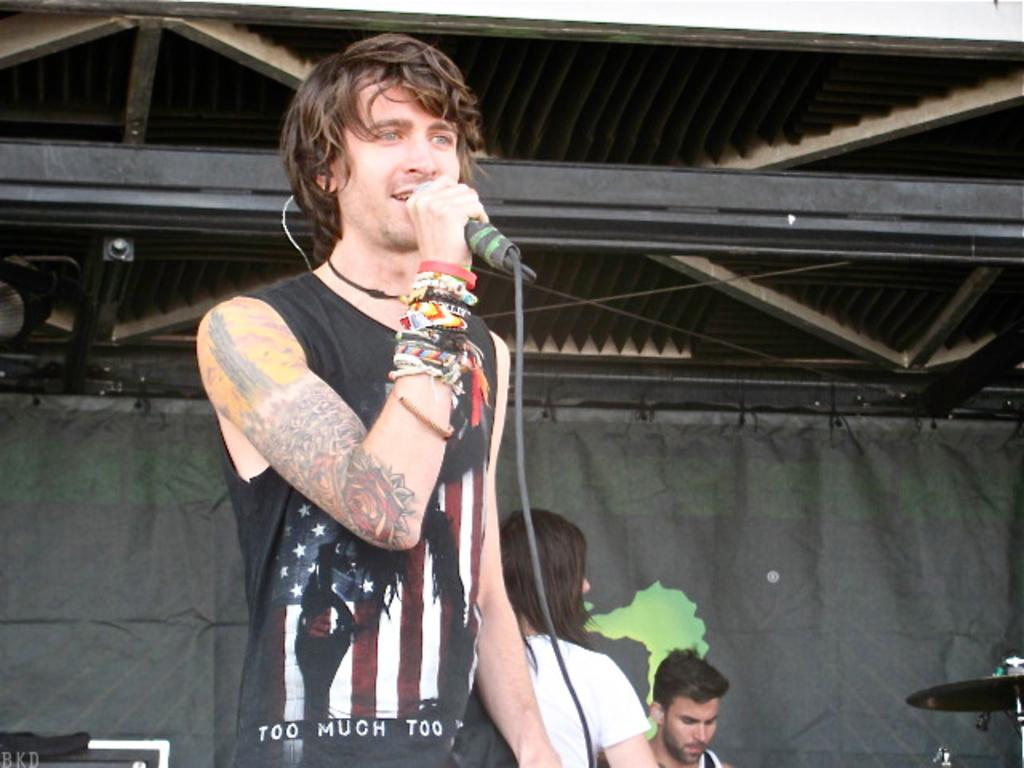What is the main subject of the image? There is a person in the image. What is the person doing in the image? The person is standing and singing a song. What object is the person holding in the image? The person is holding a microphone. What type of condition does the person have that causes them to be surrounded by spiders in the image? There are no spiders present in the image, and therefore no condition can be inferred. Is the person in the image a lawyer? There is no information about the person's profession in the image, so it cannot be determined if they are a lawyer. 